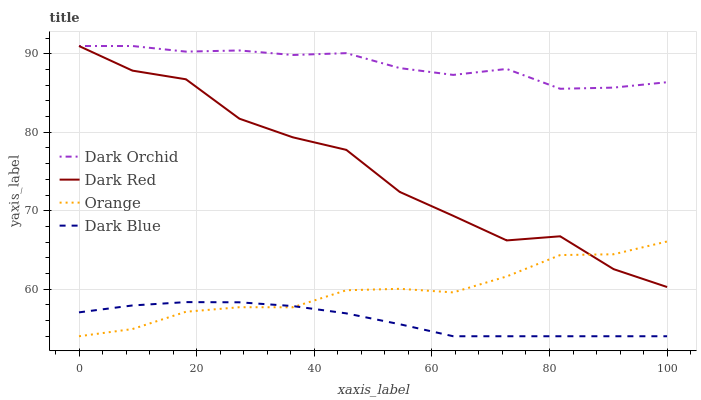Does Dark Blue have the minimum area under the curve?
Answer yes or no. Yes. Does Dark Orchid have the maximum area under the curve?
Answer yes or no. Yes. Does Dark Red have the minimum area under the curve?
Answer yes or no. No. Does Dark Red have the maximum area under the curve?
Answer yes or no. No. Is Dark Blue the smoothest?
Answer yes or no. Yes. Is Dark Red the roughest?
Answer yes or no. Yes. Is Dark Orchid the smoothest?
Answer yes or no. No. Is Dark Orchid the roughest?
Answer yes or no. No. Does Orange have the lowest value?
Answer yes or no. Yes. Does Dark Red have the lowest value?
Answer yes or no. No. Does Dark Orchid have the highest value?
Answer yes or no. Yes. Does Dark Blue have the highest value?
Answer yes or no. No. Is Dark Blue less than Dark Red?
Answer yes or no. Yes. Is Dark Orchid greater than Orange?
Answer yes or no. Yes. Does Dark Orchid intersect Dark Red?
Answer yes or no. Yes. Is Dark Orchid less than Dark Red?
Answer yes or no. No. Is Dark Orchid greater than Dark Red?
Answer yes or no. No. Does Dark Blue intersect Dark Red?
Answer yes or no. No. 